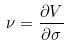<formula> <loc_0><loc_0><loc_500><loc_500>\nu = \frac { \partial V } { \partial \sigma }</formula> 